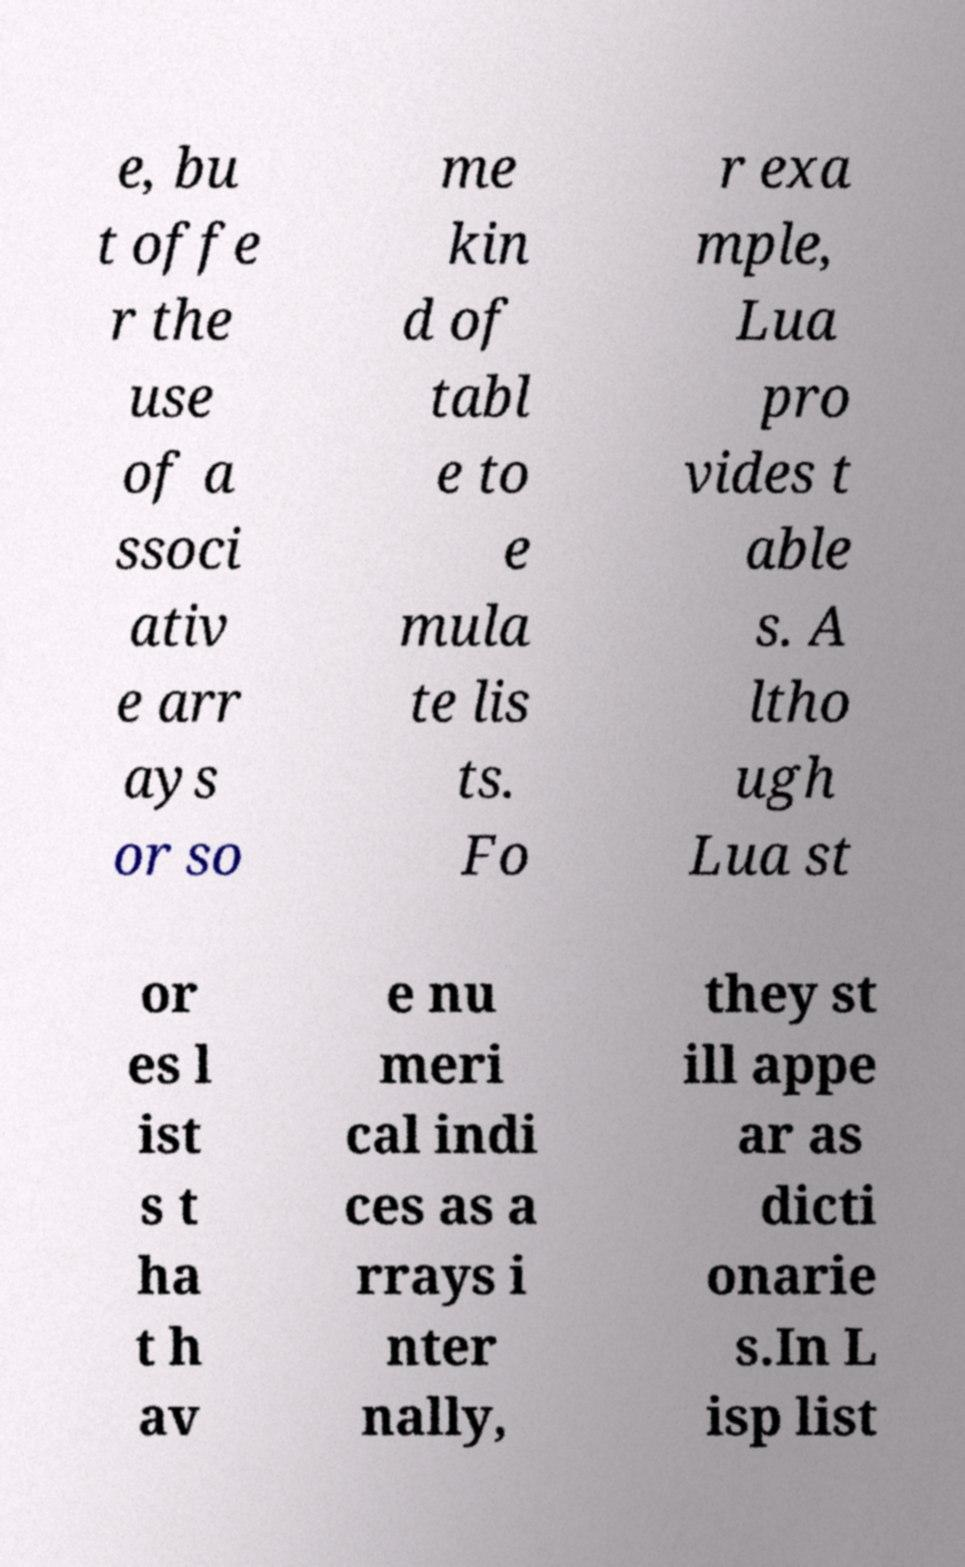What messages or text are displayed in this image? I need them in a readable, typed format. e, bu t offe r the use of a ssoci ativ e arr ays or so me kin d of tabl e to e mula te lis ts. Fo r exa mple, Lua pro vides t able s. A ltho ugh Lua st or es l ist s t ha t h av e nu meri cal indi ces as a rrays i nter nally, they st ill appe ar as dicti onarie s.In L isp list 